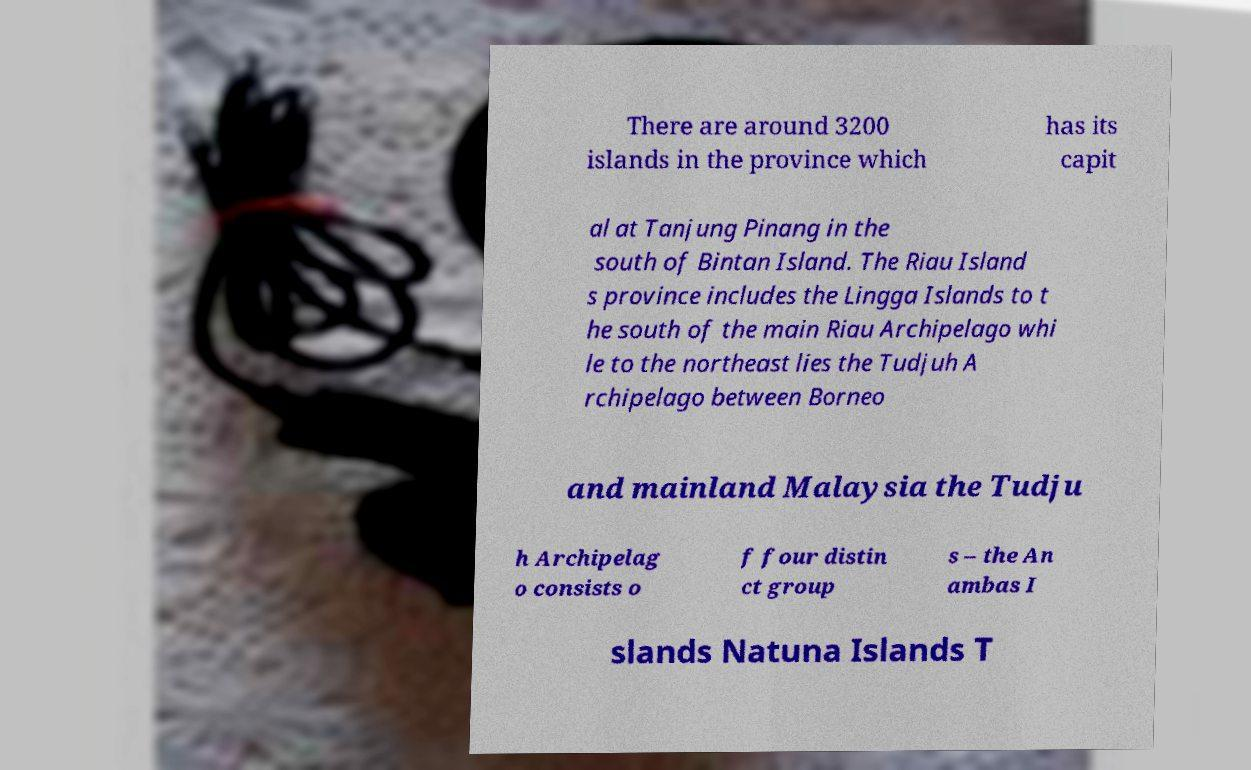Can you accurately transcribe the text from the provided image for me? There are around 3200 islands in the province which has its capit al at Tanjung Pinang in the south of Bintan Island. The Riau Island s province includes the Lingga Islands to t he south of the main Riau Archipelago whi le to the northeast lies the Tudjuh A rchipelago between Borneo and mainland Malaysia the Tudju h Archipelag o consists o f four distin ct group s – the An ambas I slands Natuna Islands T 